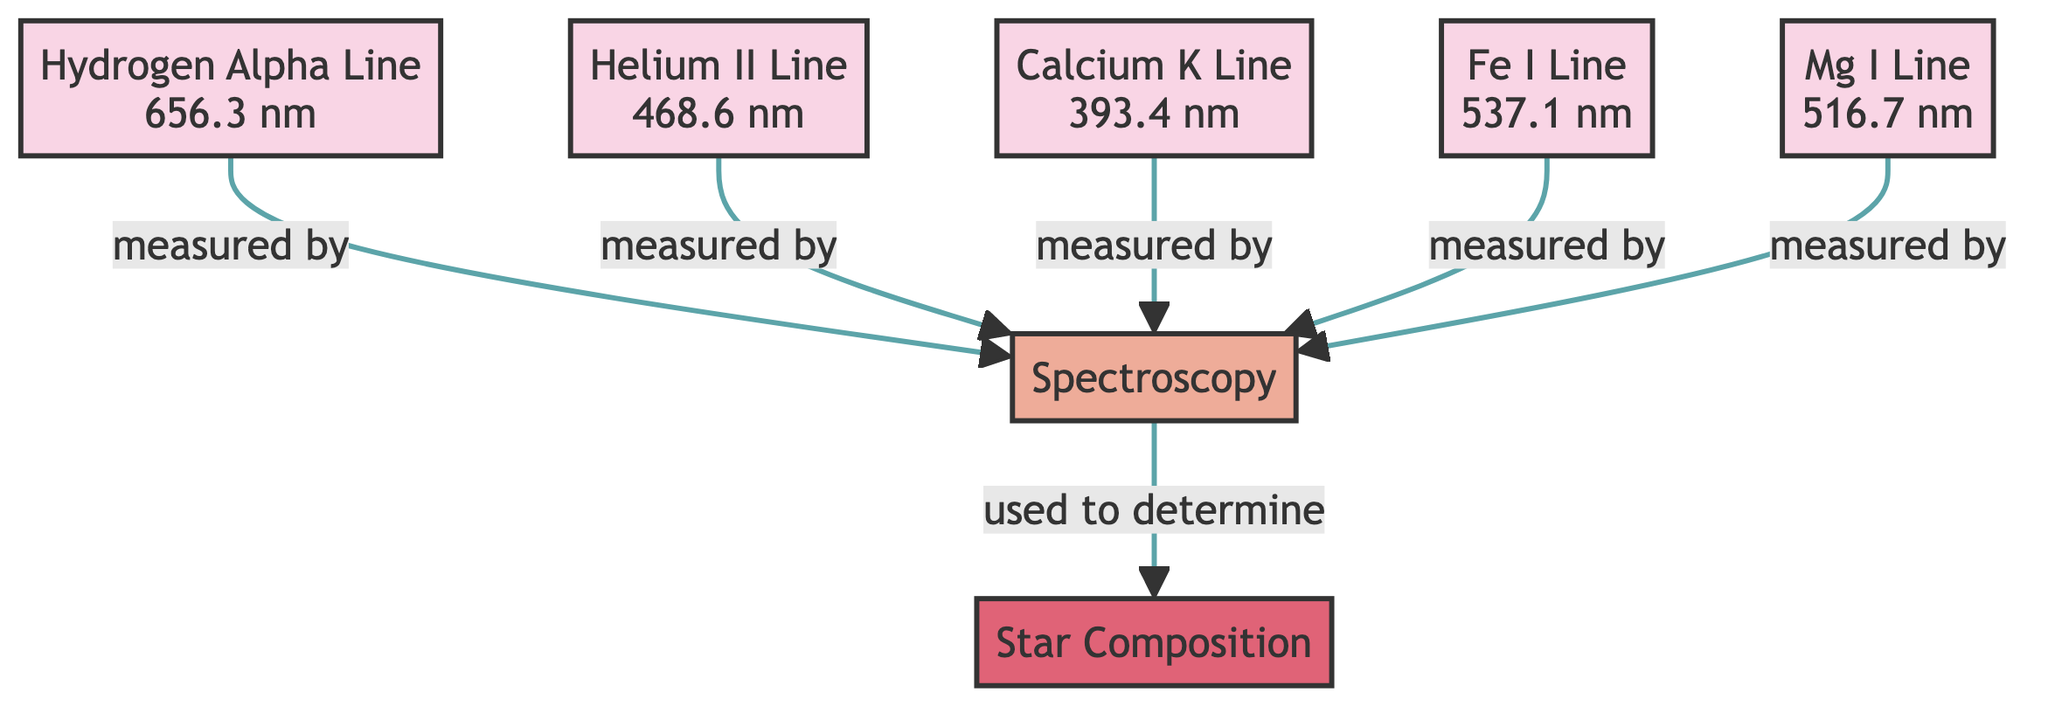What is the wavelength of the Hydrogen Alpha Line? The diagram states that the Hydrogen Alpha Line has a wavelength of 656.3 nm. This information is found directly next to the corresponding spectral line node in the diagram.
Answer: 656.3 nm How many spectral lines are represented in the diagram? By counting the number of nodes labeled as spectral lines, we find there are five distinct lines represented: Hydrogen Alpha, Helium II, Calcium K, Fe I, and Mg I.
Answer: 5 Which spectral line is associated with 468.6 nm? The diagram associates the wavelength of 468.6 nm with the Helium II Line, as indicated next to the respective spectral line node.
Answer: Helium II Line What technique is used to measure all the spectral lines? The node labeled "Spectroscopy" indicates that this technique is used to measure all listed spectral lines in the diagram. Each spectral line points towards this node.
Answer: Spectroscopy What do the measured spectral lines help to determine? According to the flow from the "Spectroscopy" node, these measurements are used to determine the "Star Composition," which is highlighted in the diagram as the final outcome of the process.
Answer: Star Composition How does the Calcium K Line relate to the technique of spectroscopy? The Calcium K Line is shown to be measured by the technique of spectroscopy, displaying a direct connection in the diagram indicating its relevance in determining stellar composition through that technique.
Answer: Measured by spectroscopy Which spectral line corresponds to the wavelength of 393.4 nm? The node corresponding to a wavelength of 393.4 nm is labeled as the Calcium K Line, providing a clear identification within the diagram's spectral line representation.
Answer: Calcium K Line What is the relationship between spectral lines and star composition? The arrows in the diagram indicate that all measured spectral lines feed into the process that determines star composition, suggesting a direct flow of information from individual spectral lines to the overall understanding of what a star is made of.
Answer: Determines star composition 